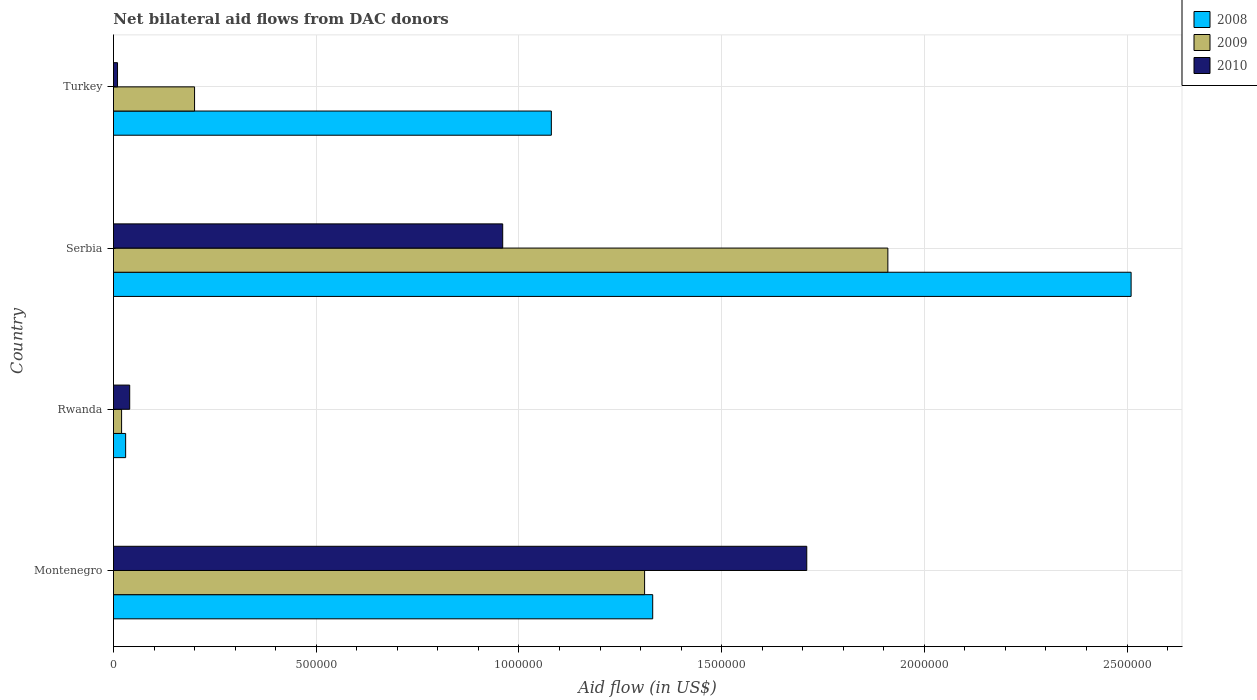How many groups of bars are there?
Give a very brief answer. 4. Are the number of bars on each tick of the Y-axis equal?
Provide a short and direct response. Yes. How many bars are there on the 3rd tick from the bottom?
Give a very brief answer. 3. What is the label of the 1st group of bars from the top?
Provide a succinct answer. Turkey. What is the net bilateral aid flow in 2009 in Turkey?
Your response must be concise. 2.00e+05. Across all countries, what is the maximum net bilateral aid flow in 2009?
Offer a very short reply. 1.91e+06. Across all countries, what is the minimum net bilateral aid flow in 2008?
Offer a terse response. 3.00e+04. In which country was the net bilateral aid flow in 2008 maximum?
Provide a short and direct response. Serbia. In which country was the net bilateral aid flow in 2010 minimum?
Provide a succinct answer. Turkey. What is the total net bilateral aid flow in 2008 in the graph?
Make the answer very short. 4.95e+06. What is the difference between the net bilateral aid flow in 2010 in Montenegro and that in Rwanda?
Offer a terse response. 1.67e+06. What is the difference between the net bilateral aid flow in 2010 in Rwanda and the net bilateral aid flow in 2008 in Turkey?
Your answer should be compact. -1.04e+06. What is the average net bilateral aid flow in 2010 per country?
Offer a terse response. 6.80e+05. What is the difference between the net bilateral aid flow in 2008 and net bilateral aid flow in 2009 in Rwanda?
Your answer should be compact. 10000. What is the ratio of the net bilateral aid flow in 2010 in Serbia to that in Turkey?
Give a very brief answer. 96. What is the difference between the highest and the second highest net bilateral aid flow in 2008?
Give a very brief answer. 1.18e+06. What is the difference between the highest and the lowest net bilateral aid flow in 2008?
Your answer should be compact. 2.48e+06. In how many countries, is the net bilateral aid flow in 2008 greater than the average net bilateral aid flow in 2008 taken over all countries?
Your answer should be compact. 2. What does the 3rd bar from the bottom in Rwanda represents?
Provide a short and direct response. 2010. How many bars are there?
Offer a terse response. 12. How many countries are there in the graph?
Give a very brief answer. 4. Are the values on the major ticks of X-axis written in scientific E-notation?
Keep it short and to the point. No. Does the graph contain any zero values?
Ensure brevity in your answer.  No. Does the graph contain grids?
Make the answer very short. Yes. How are the legend labels stacked?
Your answer should be very brief. Vertical. What is the title of the graph?
Your response must be concise. Net bilateral aid flows from DAC donors. What is the label or title of the X-axis?
Your answer should be compact. Aid flow (in US$). What is the Aid flow (in US$) in 2008 in Montenegro?
Provide a succinct answer. 1.33e+06. What is the Aid flow (in US$) in 2009 in Montenegro?
Make the answer very short. 1.31e+06. What is the Aid flow (in US$) in 2010 in Montenegro?
Your answer should be compact. 1.71e+06. What is the Aid flow (in US$) of 2008 in Rwanda?
Provide a succinct answer. 3.00e+04. What is the Aid flow (in US$) in 2010 in Rwanda?
Ensure brevity in your answer.  4.00e+04. What is the Aid flow (in US$) in 2008 in Serbia?
Ensure brevity in your answer.  2.51e+06. What is the Aid flow (in US$) of 2009 in Serbia?
Make the answer very short. 1.91e+06. What is the Aid flow (in US$) in 2010 in Serbia?
Provide a short and direct response. 9.60e+05. What is the Aid flow (in US$) of 2008 in Turkey?
Offer a terse response. 1.08e+06. What is the Aid flow (in US$) in 2010 in Turkey?
Offer a very short reply. 10000. Across all countries, what is the maximum Aid flow (in US$) of 2008?
Ensure brevity in your answer.  2.51e+06. Across all countries, what is the maximum Aid flow (in US$) of 2009?
Provide a short and direct response. 1.91e+06. Across all countries, what is the maximum Aid flow (in US$) in 2010?
Your answer should be compact. 1.71e+06. Across all countries, what is the minimum Aid flow (in US$) in 2008?
Give a very brief answer. 3.00e+04. Across all countries, what is the minimum Aid flow (in US$) in 2009?
Your response must be concise. 2.00e+04. What is the total Aid flow (in US$) in 2008 in the graph?
Provide a succinct answer. 4.95e+06. What is the total Aid flow (in US$) in 2009 in the graph?
Your response must be concise. 3.44e+06. What is the total Aid flow (in US$) in 2010 in the graph?
Your answer should be compact. 2.72e+06. What is the difference between the Aid flow (in US$) in 2008 in Montenegro and that in Rwanda?
Ensure brevity in your answer.  1.30e+06. What is the difference between the Aid flow (in US$) of 2009 in Montenegro and that in Rwanda?
Your answer should be very brief. 1.29e+06. What is the difference between the Aid flow (in US$) of 2010 in Montenegro and that in Rwanda?
Make the answer very short. 1.67e+06. What is the difference between the Aid flow (in US$) in 2008 in Montenegro and that in Serbia?
Offer a terse response. -1.18e+06. What is the difference between the Aid flow (in US$) of 2009 in Montenegro and that in Serbia?
Provide a succinct answer. -6.00e+05. What is the difference between the Aid flow (in US$) of 2010 in Montenegro and that in Serbia?
Provide a short and direct response. 7.50e+05. What is the difference between the Aid flow (in US$) in 2009 in Montenegro and that in Turkey?
Ensure brevity in your answer.  1.11e+06. What is the difference between the Aid flow (in US$) of 2010 in Montenegro and that in Turkey?
Ensure brevity in your answer.  1.70e+06. What is the difference between the Aid flow (in US$) of 2008 in Rwanda and that in Serbia?
Make the answer very short. -2.48e+06. What is the difference between the Aid flow (in US$) of 2009 in Rwanda and that in Serbia?
Keep it short and to the point. -1.89e+06. What is the difference between the Aid flow (in US$) of 2010 in Rwanda and that in Serbia?
Offer a very short reply. -9.20e+05. What is the difference between the Aid flow (in US$) in 2008 in Rwanda and that in Turkey?
Keep it short and to the point. -1.05e+06. What is the difference between the Aid flow (in US$) of 2009 in Rwanda and that in Turkey?
Provide a succinct answer. -1.80e+05. What is the difference between the Aid flow (in US$) of 2010 in Rwanda and that in Turkey?
Give a very brief answer. 3.00e+04. What is the difference between the Aid flow (in US$) in 2008 in Serbia and that in Turkey?
Your response must be concise. 1.43e+06. What is the difference between the Aid flow (in US$) in 2009 in Serbia and that in Turkey?
Your answer should be very brief. 1.71e+06. What is the difference between the Aid flow (in US$) in 2010 in Serbia and that in Turkey?
Keep it short and to the point. 9.50e+05. What is the difference between the Aid flow (in US$) in 2008 in Montenegro and the Aid flow (in US$) in 2009 in Rwanda?
Provide a succinct answer. 1.31e+06. What is the difference between the Aid flow (in US$) in 2008 in Montenegro and the Aid flow (in US$) in 2010 in Rwanda?
Provide a succinct answer. 1.29e+06. What is the difference between the Aid flow (in US$) of 2009 in Montenegro and the Aid flow (in US$) of 2010 in Rwanda?
Ensure brevity in your answer.  1.27e+06. What is the difference between the Aid flow (in US$) of 2008 in Montenegro and the Aid flow (in US$) of 2009 in Serbia?
Make the answer very short. -5.80e+05. What is the difference between the Aid flow (in US$) of 2008 in Montenegro and the Aid flow (in US$) of 2010 in Serbia?
Your answer should be compact. 3.70e+05. What is the difference between the Aid flow (in US$) in 2008 in Montenegro and the Aid flow (in US$) in 2009 in Turkey?
Make the answer very short. 1.13e+06. What is the difference between the Aid flow (in US$) in 2008 in Montenegro and the Aid flow (in US$) in 2010 in Turkey?
Offer a terse response. 1.32e+06. What is the difference between the Aid flow (in US$) in 2009 in Montenegro and the Aid flow (in US$) in 2010 in Turkey?
Give a very brief answer. 1.30e+06. What is the difference between the Aid flow (in US$) in 2008 in Rwanda and the Aid flow (in US$) in 2009 in Serbia?
Provide a short and direct response. -1.88e+06. What is the difference between the Aid flow (in US$) in 2008 in Rwanda and the Aid flow (in US$) in 2010 in Serbia?
Offer a terse response. -9.30e+05. What is the difference between the Aid flow (in US$) of 2009 in Rwanda and the Aid flow (in US$) of 2010 in Serbia?
Give a very brief answer. -9.40e+05. What is the difference between the Aid flow (in US$) of 2008 in Rwanda and the Aid flow (in US$) of 2009 in Turkey?
Your answer should be very brief. -1.70e+05. What is the difference between the Aid flow (in US$) of 2008 in Rwanda and the Aid flow (in US$) of 2010 in Turkey?
Provide a short and direct response. 2.00e+04. What is the difference between the Aid flow (in US$) of 2008 in Serbia and the Aid flow (in US$) of 2009 in Turkey?
Your response must be concise. 2.31e+06. What is the difference between the Aid flow (in US$) of 2008 in Serbia and the Aid flow (in US$) of 2010 in Turkey?
Offer a terse response. 2.50e+06. What is the difference between the Aid flow (in US$) in 2009 in Serbia and the Aid flow (in US$) in 2010 in Turkey?
Your response must be concise. 1.90e+06. What is the average Aid flow (in US$) in 2008 per country?
Keep it short and to the point. 1.24e+06. What is the average Aid flow (in US$) in 2009 per country?
Your answer should be very brief. 8.60e+05. What is the average Aid flow (in US$) in 2010 per country?
Offer a terse response. 6.80e+05. What is the difference between the Aid flow (in US$) of 2008 and Aid flow (in US$) of 2009 in Montenegro?
Make the answer very short. 2.00e+04. What is the difference between the Aid flow (in US$) in 2008 and Aid flow (in US$) in 2010 in Montenegro?
Make the answer very short. -3.80e+05. What is the difference between the Aid flow (in US$) in 2009 and Aid flow (in US$) in 2010 in Montenegro?
Provide a succinct answer. -4.00e+05. What is the difference between the Aid flow (in US$) in 2008 and Aid flow (in US$) in 2009 in Rwanda?
Give a very brief answer. 10000. What is the difference between the Aid flow (in US$) of 2008 and Aid flow (in US$) of 2010 in Rwanda?
Give a very brief answer. -10000. What is the difference between the Aid flow (in US$) of 2008 and Aid flow (in US$) of 2010 in Serbia?
Your answer should be very brief. 1.55e+06. What is the difference between the Aid flow (in US$) of 2009 and Aid flow (in US$) of 2010 in Serbia?
Keep it short and to the point. 9.50e+05. What is the difference between the Aid flow (in US$) of 2008 and Aid flow (in US$) of 2009 in Turkey?
Your answer should be compact. 8.80e+05. What is the difference between the Aid flow (in US$) of 2008 and Aid flow (in US$) of 2010 in Turkey?
Give a very brief answer. 1.07e+06. What is the difference between the Aid flow (in US$) of 2009 and Aid flow (in US$) of 2010 in Turkey?
Provide a succinct answer. 1.90e+05. What is the ratio of the Aid flow (in US$) of 2008 in Montenegro to that in Rwanda?
Provide a short and direct response. 44.33. What is the ratio of the Aid flow (in US$) of 2009 in Montenegro to that in Rwanda?
Your answer should be compact. 65.5. What is the ratio of the Aid flow (in US$) in 2010 in Montenegro to that in Rwanda?
Keep it short and to the point. 42.75. What is the ratio of the Aid flow (in US$) of 2008 in Montenegro to that in Serbia?
Offer a terse response. 0.53. What is the ratio of the Aid flow (in US$) in 2009 in Montenegro to that in Serbia?
Offer a terse response. 0.69. What is the ratio of the Aid flow (in US$) in 2010 in Montenegro to that in Serbia?
Give a very brief answer. 1.78. What is the ratio of the Aid flow (in US$) in 2008 in Montenegro to that in Turkey?
Offer a very short reply. 1.23. What is the ratio of the Aid flow (in US$) of 2009 in Montenegro to that in Turkey?
Give a very brief answer. 6.55. What is the ratio of the Aid flow (in US$) in 2010 in Montenegro to that in Turkey?
Give a very brief answer. 171. What is the ratio of the Aid flow (in US$) in 2008 in Rwanda to that in Serbia?
Your response must be concise. 0.01. What is the ratio of the Aid flow (in US$) of 2009 in Rwanda to that in Serbia?
Offer a terse response. 0.01. What is the ratio of the Aid flow (in US$) of 2010 in Rwanda to that in Serbia?
Provide a short and direct response. 0.04. What is the ratio of the Aid flow (in US$) of 2008 in Rwanda to that in Turkey?
Offer a terse response. 0.03. What is the ratio of the Aid flow (in US$) in 2008 in Serbia to that in Turkey?
Offer a terse response. 2.32. What is the ratio of the Aid flow (in US$) in 2009 in Serbia to that in Turkey?
Provide a succinct answer. 9.55. What is the ratio of the Aid flow (in US$) in 2010 in Serbia to that in Turkey?
Make the answer very short. 96. What is the difference between the highest and the second highest Aid flow (in US$) in 2008?
Provide a succinct answer. 1.18e+06. What is the difference between the highest and the second highest Aid flow (in US$) of 2010?
Keep it short and to the point. 7.50e+05. What is the difference between the highest and the lowest Aid flow (in US$) in 2008?
Ensure brevity in your answer.  2.48e+06. What is the difference between the highest and the lowest Aid flow (in US$) of 2009?
Ensure brevity in your answer.  1.89e+06. What is the difference between the highest and the lowest Aid flow (in US$) of 2010?
Your response must be concise. 1.70e+06. 